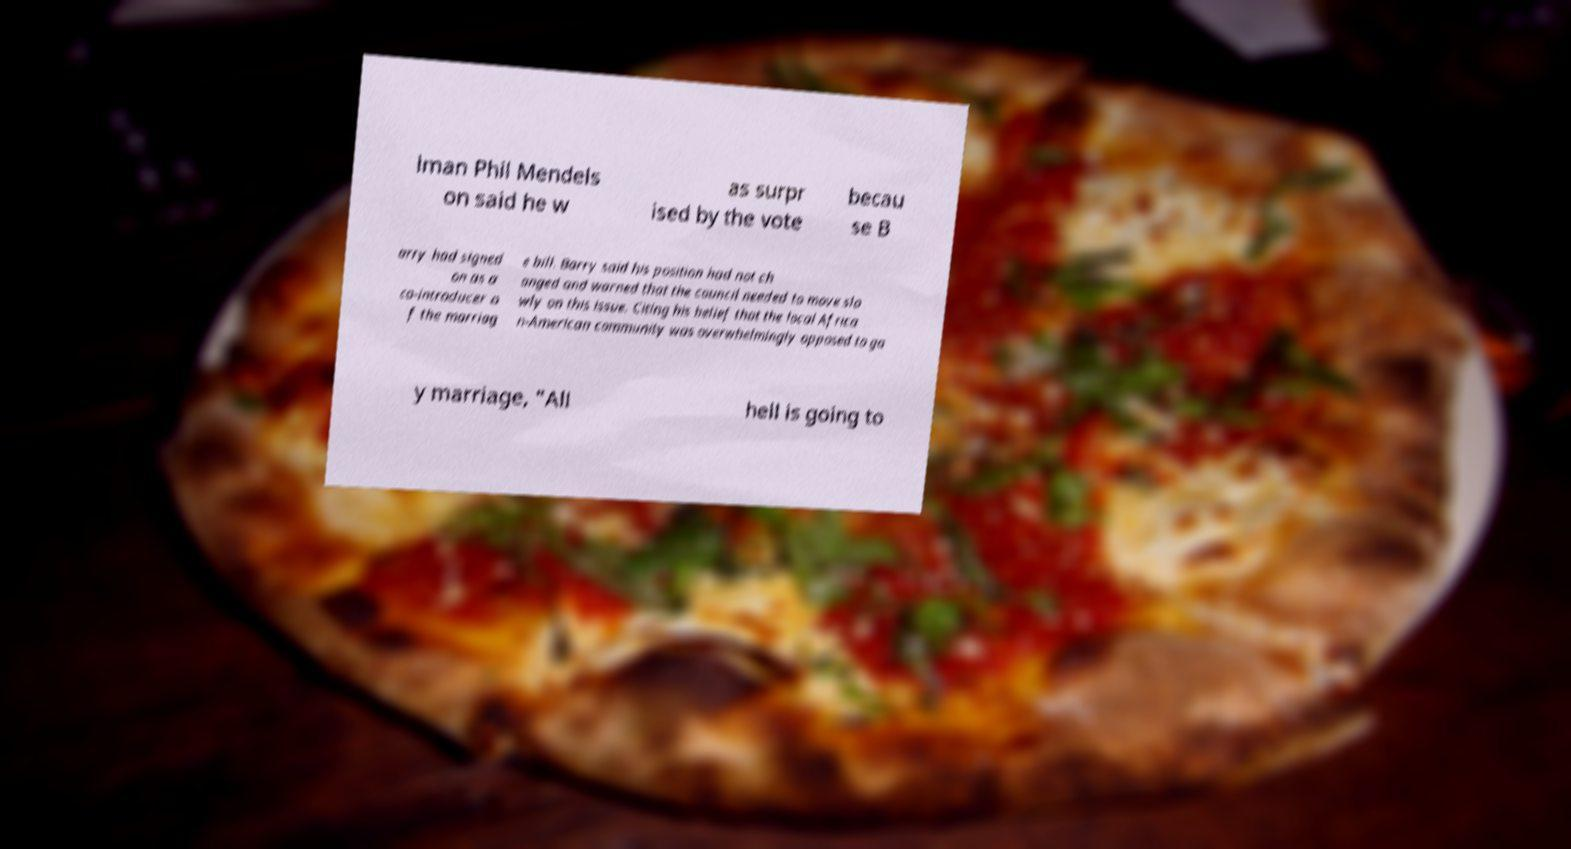Please identify and transcribe the text found in this image. lman Phil Mendels on said he w as surpr ised by the vote becau se B arry had signed on as a co-introducer o f the marriag e bill. Barry said his position had not ch anged and warned that the council needed to move slo wly on this issue. Citing his belief that the local Africa n-American community was overwhelmingly opposed to ga y marriage, "All hell is going to 